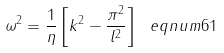<formula> <loc_0><loc_0><loc_500><loc_500>\omega ^ { 2 } = \frac { 1 } { \eta } \left [ k ^ { 2 } - \frac { \pi ^ { 2 } } { l ^ { 2 } } \right ] \ e q n u m { 6 1 }</formula> 